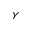<formula> <loc_0><loc_0><loc_500><loc_500>\gamma</formula> 